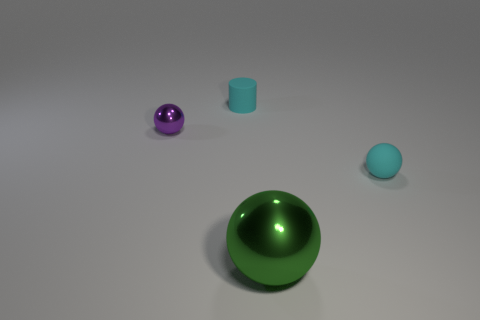How many objects are either small cyan matte objects or tiny rubber things in front of the small purple ball?
Keep it short and to the point. 2. How many other things are the same size as the green metallic thing?
Make the answer very short. 0. Are the ball on the right side of the green metal object and the object that is to the left of the small cylinder made of the same material?
Offer a very short reply. No. How many green objects are behind the cyan matte sphere?
Give a very brief answer. 0. How many yellow things are either big metallic spheres or metallic objects?
Ensure brevity in your answer.  0. There is a cyan object that is the same size as the cyan cylinder; what is its material?
Make the answer very short. Rubber. There is a small thing that is both to the right of the purple ball and behind the tiny cyan sphere; what shape is it?
Give a very brief answer. Cylinder. There is a matte thing that is the same size as the matte cylinder; what color is it?
Offer a terse response. Cyan. There is a cyan matte thing behind the cyan matte sphere; does it have the same size as the metallic ball on the left side of the large green sphere?
Your response must be concise. Yes. There is a cyan thing that is behind the shiny object left of the tiny matte object behind the cyan rubber sphere; how big is it?
Ensure brevity in your answer.  Small. 